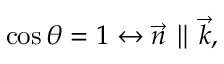Convert formula to latex. <formula><loc_0><loc_0><loc_500><loc_500>\cos \theta = 1 \leftrightarrow \vec { n } \| \vec { k } ,</formula> 